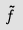Convert formula to latex. <formula><loc_0><loc_0><loc_500><loc_500>\tilde { f }</formula> 